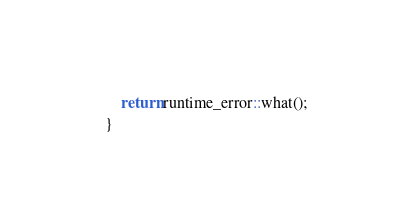Convert code to text. <code><loc_0><loc_0><loc_500><loc_500><_C++_>    return runtime_error::what();
}
</code> 